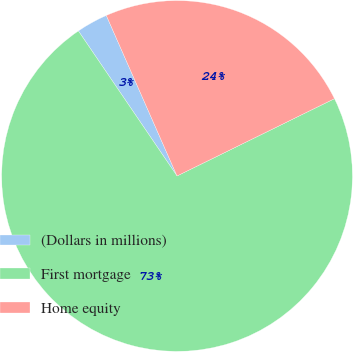<chart> <loc_0><loc_0><loc_500><loc_500><pie_chart><fcel>(Dollars in millions)<fcel>First mortgage<fcel>Home equity<nl><fcel>2.9%<fcel>72.76%<fcel>24.34%<nl></chart> 